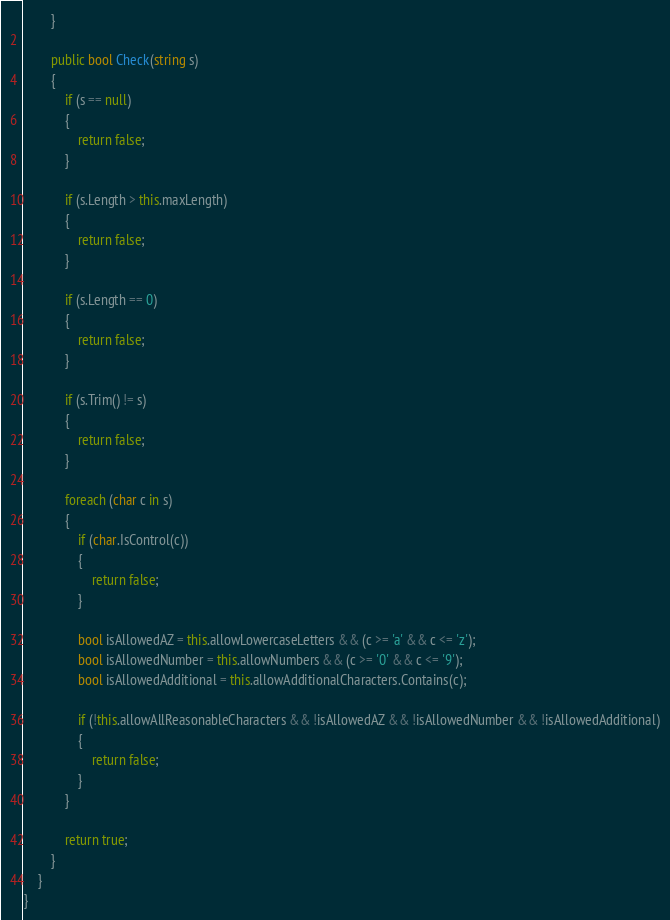Convert code to text. <code><loc_0><loc_0><loc_500><loc_500><_C#_>        }

        public bool Check(string s)
        {
            if (s == null)
            {
                return false;
            }

            if (s.Length > this.maxLength)
            {
                return false;
            }

            if (s.Length == 0)
            {
                return false;
            }

            if (s.Trim() != s)
            {
                return false;
            }

            foreach (char c in s)
            {
                if (char.IsControl(c))
                {
                    return false;
                }

                bool isAllowedAZ = this.allowLowercaseLetters && (c >= 'a' && c <= 'z');
                bool isAllowedNumber = this.allowNumbers && (c >= '0' && c <= '9');
                bool isAllowedAdditional = this.allowAdditionalCharacters.Contains(c);

                if (!this.allowAllReasonableCharacters && !isAllowedAZ && !isAllowedNumber && !isAllowedAdditional)
                {
                    return false;
                }
            }

            return true;
        }
    }
}</code> 